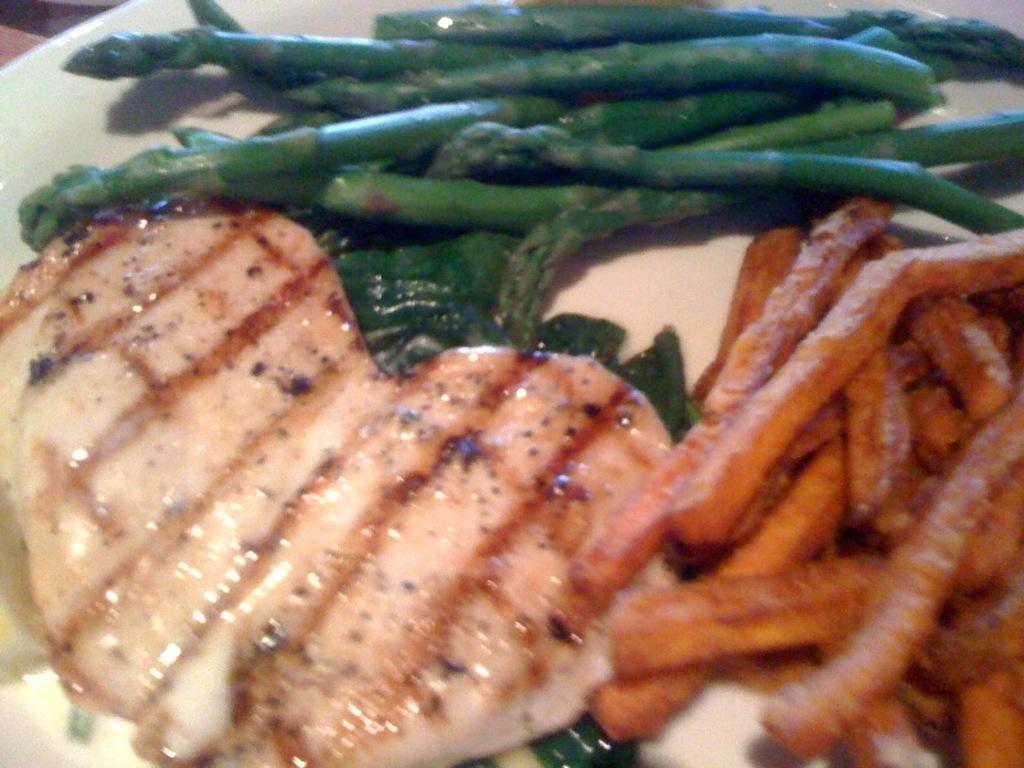What is on the plate in the image? There are food items on the plate. Can you identify any specific food items on the plate? Yes, French fries are present on the plate. How many chickens can be seen on the plate in the image? There are no chickens present on the plate in the image. 